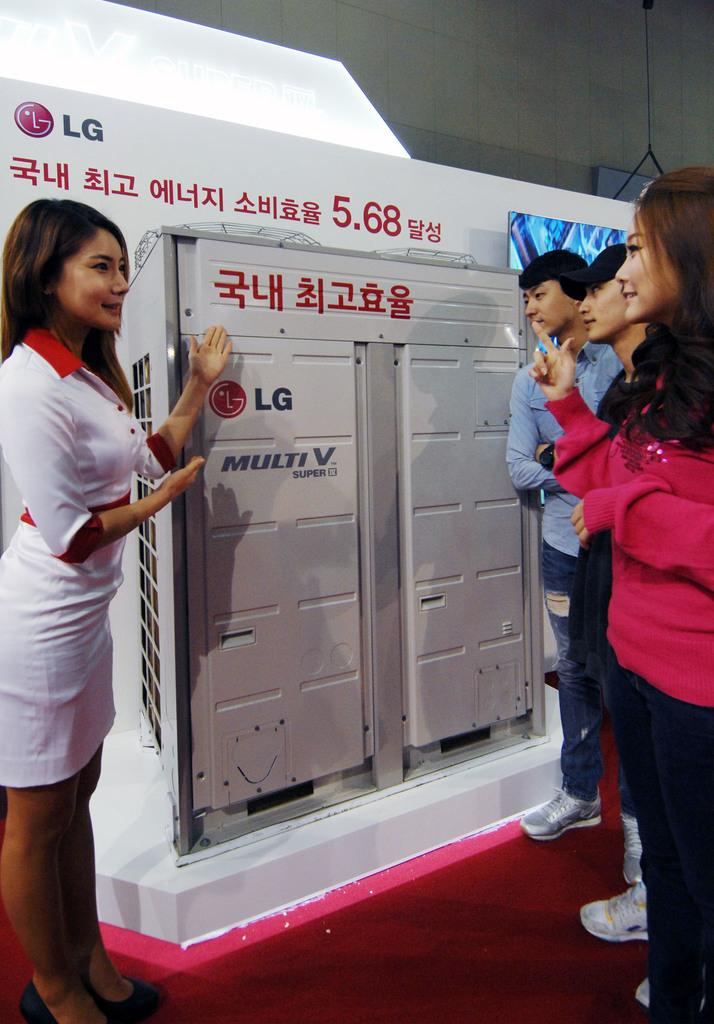<image>
Create a compact narrative representing the image presented. A woman presents LG products to consumers at a show. 